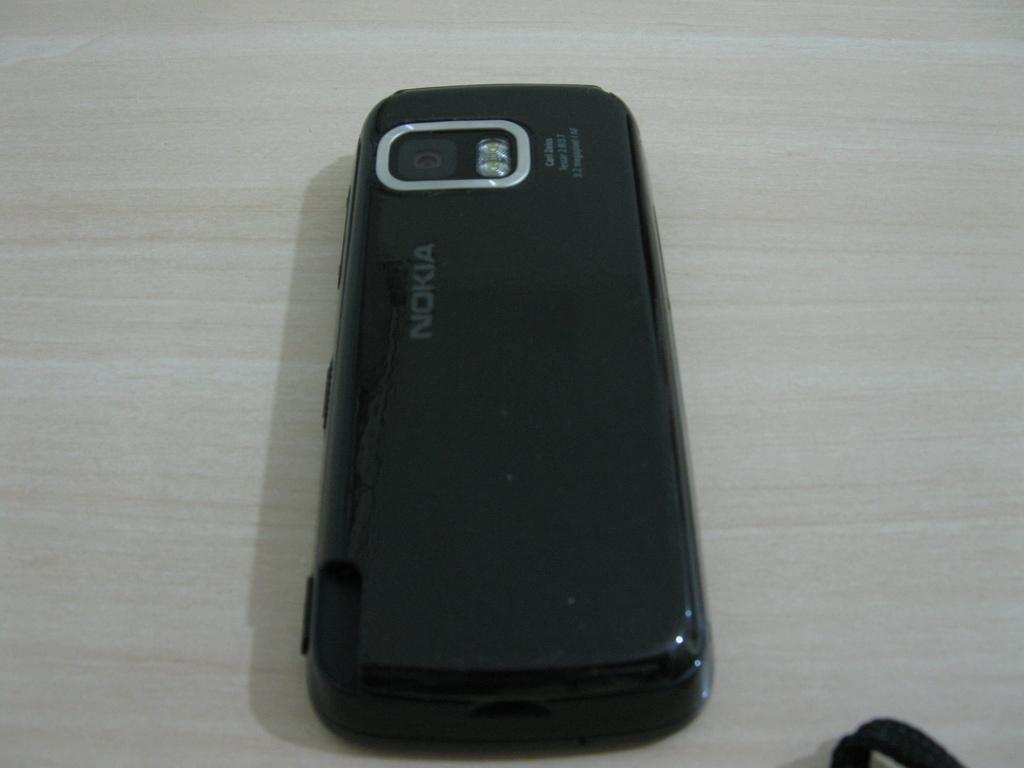<image>
Give a short and clear explanation of the subsequent image. A nokia cell phone sits face down on a desk. 